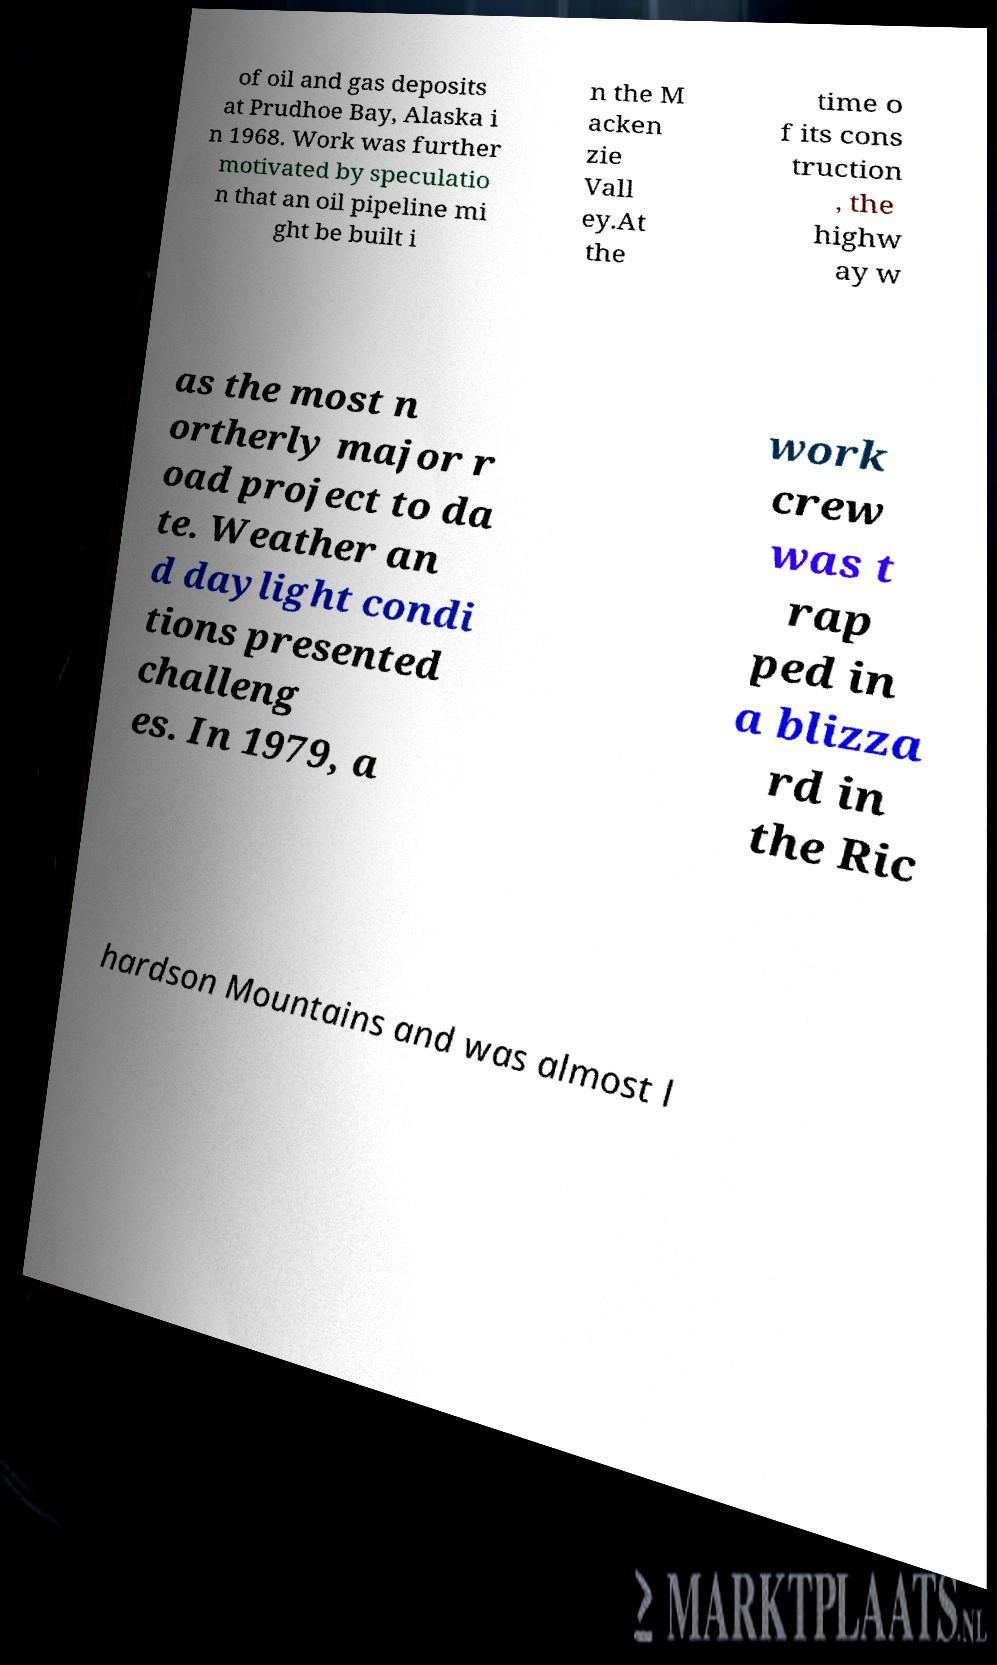Could you assist in decoding the text presented in this image and type it out clearly? of oil and gas deposits at Prudhoe Bay, Alaska i n 1968. Work was further motivated by speculatio n that an oil pipeline mi ght be built i n the M acken zie Vall ey.At the time o f its cons truction , the highw ay w as the most n ortherly major r oad project to da te. Weather an d daylight condi tions presented challeng es. In 1979, a work crew was t rap ped in a blizza rd in the Ric hardson Mountains and was almost l 